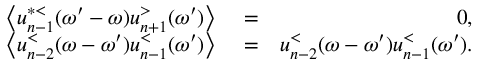<formula> <loc_0><loc_0><loc_500><loc_500>\begin{array} { r l r } { \left \langle u _ { n - 1 } ^ { * < } ( \omega ^ { \prime } - \omega ) u _ { n + 1 } ^ { > } ( \omega ^ { \prime } ) \right \rangle } & = } & { 0 , } \\ { \left \langle u _ { n - 2 } ^ { < } ( \omega - \omega ^ { \prime } ) u _ { n - 1 } ^ { < } ( \omega ^ { \prime } ) \right \rangle } & = } & { u _ { n - 2 } ^ { < } ( \omega - \omega ^ { \prime } ) u _ { n - 1 } ^ { < } ( \omega ^ { \prime } ) . } \end{array}</formula> 